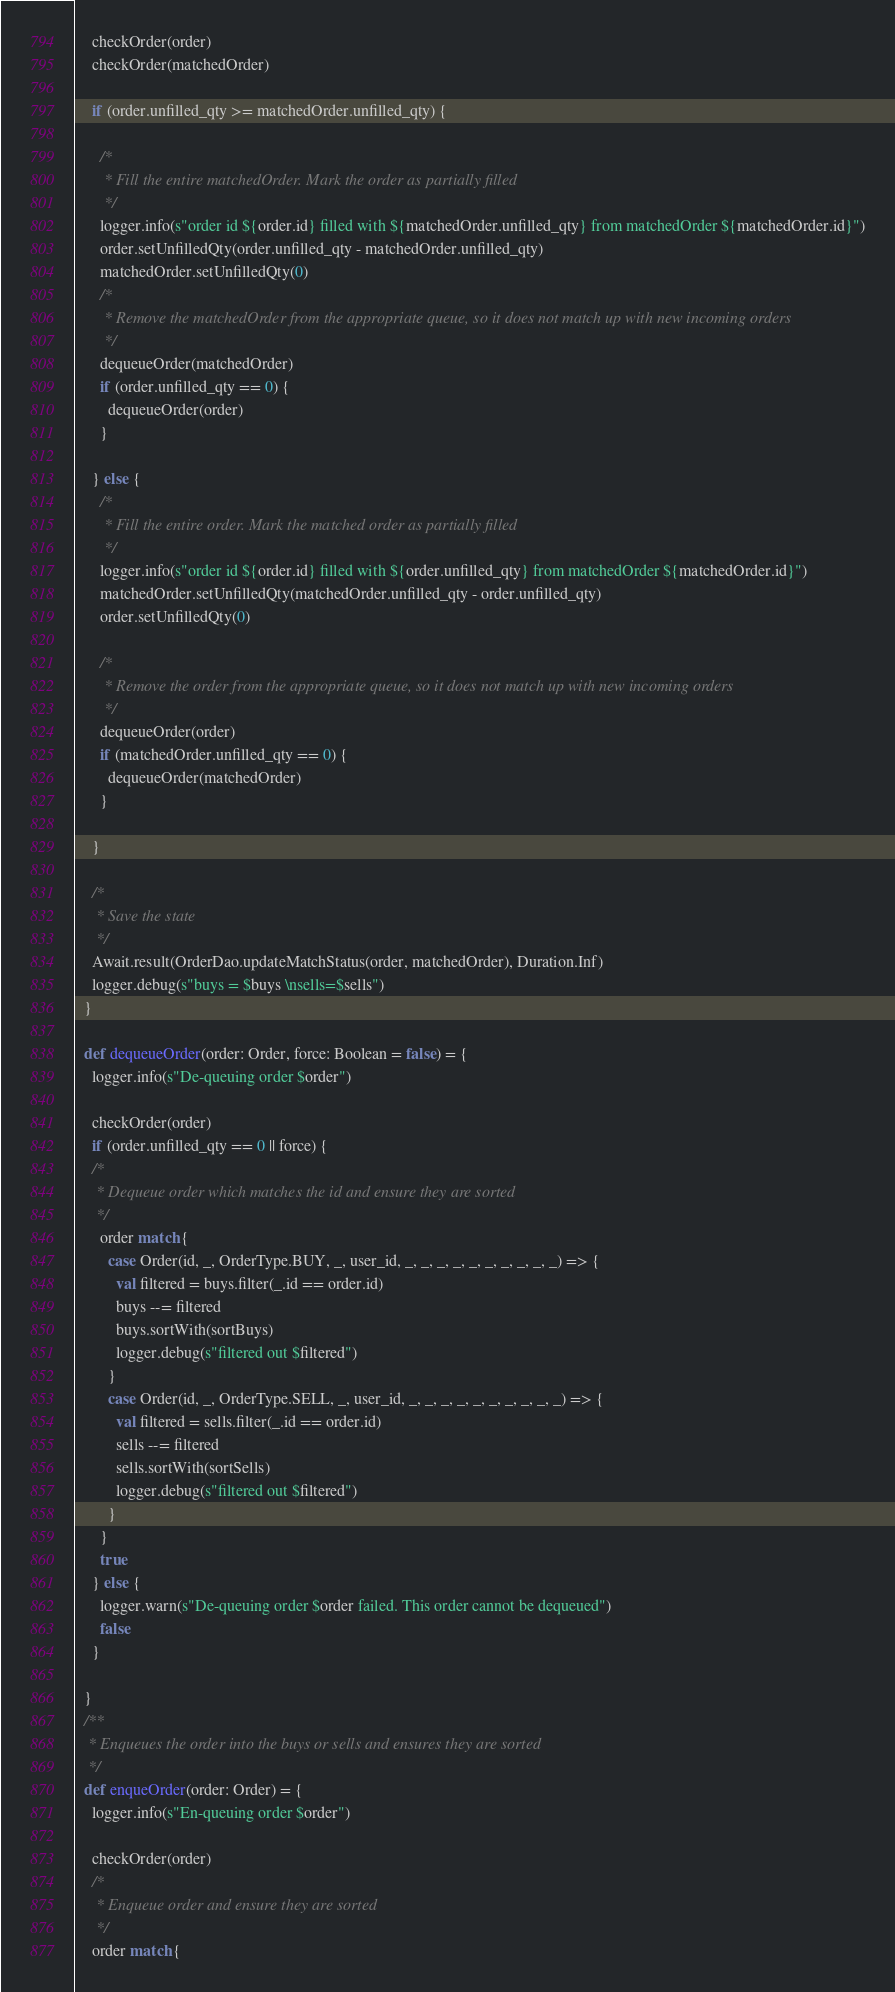<code> <loc_0><loc_0><loc_500><loc_500><_Scala_>
    checkOrder(order)
    checkOrder(matchedOrder)

    if (order.unfilled_qty >= matchedOrder.unfilled_qty) {

      /*
       * Fill the entire matchedOrder. Mark the order as partially filled
       */
      logger.info(s"order id ${order.id} filled with ${matchedOrder.unfilled_qty} from matchedOrder ${matchedOrder.id}")
      order.setUnfilledQty(order.unfilled_qty - matchedOrder.unfilled_qty)
      matchedOrder.setUnfilledQty(0)
      /*
       * Remove the matchedOrder from the appropriate queue, so it does not match up with new incoming orders
       */
      dequeueOrder(matchedOrder)
      if (order.unfilled_qty == 0) {
        dequeueOrder(order)
      }

    } else {
      /*
       * Fill the entire order. Mark the matched order as partially filled
       */
      logger.info(s"order id ${order.id} filled with ${order.unfilled_qty} from matchedOrder ${matchedOrder.id}")
      matchedOrder.setUnfilledQty(matchedOrder.unfilled_qty - order.unfilled_qty)
      order.setUnfilledQty(0)

      /*
       * Remove the order from the appropriate queue, so it does not match up with new incoming orders
       */
      dequeueOrder(order)
      if (matchedOrder.unfilled_qty == 0) {
        dequeueOrder(matchedOrder)
      }

    }

    /*
     * Save the state
     */
    Await.result(OrderDao.updateMatchStatus(order, matchedOrder), Duration.Inf)
    logger.debug(s"buys = $buys \nsells=$sells")
  }

  def dequeueOrder(order: Order, force: Boolean = false) = {
    logger.info(s"De-queuing order $order")

    checkOrder(order)
    if (order.unfilled_qty == 0 || force) {
    /*
     * Dequeue order which matches the id and ensure they are sorted
     */
      order match {
        case Order(id, _, OrderType.BUY, _, user_id, _, _, _, _, _, _, _, _, _, _) => {
          val filtered = buys.filter(_.id == order.id)
          buys --= filtered
          buys.sortWith(sortBuys)
          logger.debug(s"filtered out $filtered")
        }
        case Order(id, _, OrderType.SELL, _, user_id, _, _, _, _, _, _, _, _, _, _) => {
          val filtered = sells.filter(_.id == order.id)
          sells --= filtered
          sells.sortWith(sortSells)
          logger.debug(s"filtered out $filtered")
        }
      }
      true
    } else {
      logger.warn(s"De-queuing order $order failed. This order cannot be dequeued")
      false
    }

  }
  /**
   * Enqueues the order into the buys or sells and ensures they are sorted
   */
  def enqueOrder(order: Order) = {
    logger.info(s"En-queuing order $order")

    checkOrder(order)
    /*
     * Enqueue order and ensure they are sorted
     */
    order match {</code> 